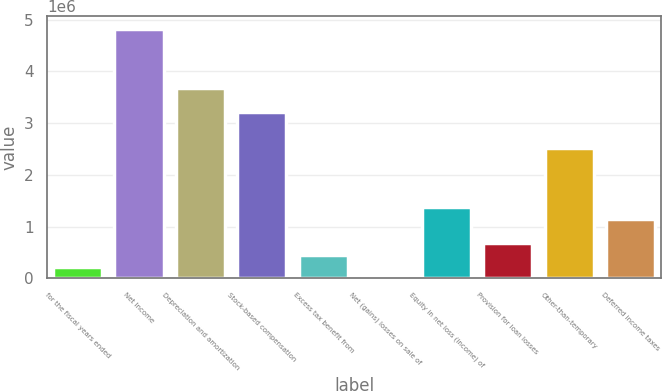Convert chart. <chart><loc_0><loc_0><loc_500><loc_500><bar_chart><fcel>for the fiscal years ended<fcel>Net Income<fcel>Depreciation and amortization<fcel>Stock-based compensation<fcel>Excess tax benefit from<fcel>Net (gains) losses on sale of<fcel>Equity in net loss (income) of<fcel>Provision for loan losses<fcel>Other-than-temporary<fcel>Deferred income taxes<nl><fcel>231184<fcel>4.82155e+06<fcel>3.67396e+06<fcel>3.21492e+06<fcel>460702<fcel>1665<fcel>1.37878e+06<fcel>690220<fcel>2.52637e+06<fcel>1.14926e+06<nl></chart> 